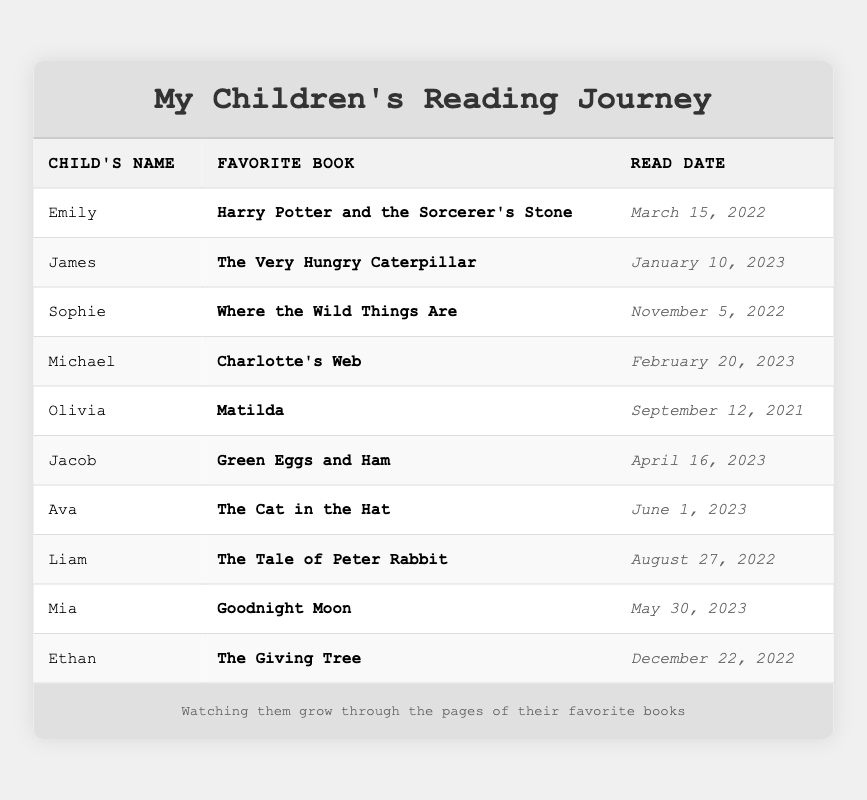What is the favorite book of Michael? According to the table, Michael's favorite book is listed under his name in the corresponding column.
Answer: Charlotte's Web How many children read their favorite book in 2023? By reviewing the Read Date column, I can count the number of entries that list a year of 2023, which are James, Michael, Jacob, Ava, and Mia. That's 5 children.
Answer: 5 Which child read "Goodnight Moon"? The table shows that "Goodnight Moon" is next to Mia's name in the Favorite Book column.
Answer: Mia Was "The Giving Tree" read before January 1, 2023? Looking at the Read Date for "The Giving Tree," it is listed as December 22, 2022, which is indeed before January 1, 2023.
Answer: Yes What is the earliest read date among these books? To find the earliest read date, I should look for the date that is the least when comparing all dates. The earliest date is September 12, 2021, which belongs to Olivia for the book "Matilda."
Answer: September 12, 2021 How many books were read after March 15, 2022? I will count how many Read Dates are after March 15, 2022. These are the entries for James, Michael, Jacob, Ava, Mia, and Ethan, totaling 6 books.
Answer: 6 Which book did Olivia read? Olivia's favorite book is listed directly in the table next to her name.
Answer: Matilda Who are the two children that read their favorite book on the same day? The entries for Jacob and Ava show that both have a read date of June 1, 2023, upon examining the table.
Answer: Jacob and Ava How many children chose books that were read in the latter half of 2022? The Read Dates for the latter half of 2022 are those in the months of July to December. The entries for Sophie, Ethan, and Liam fall in that range, giving a total of 3 children.
Answer: 3 Which book was the most recently read? Checking the Read Date column, Jacob's book "Green Eggs and Ham" read on April 16, 2023, is the latest date, making it the most recently read book.
Answer: Green Eggs and Ham 